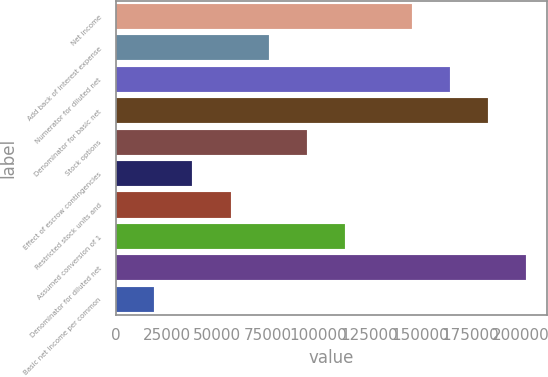<chart> <loc_0><loc_0><loc_500><loc_500><bar_chart><fcel>Net income<fcel>Add back of interest expense<fcel>Numerator for diluted net<fcel>Denominator for basic net<fcel>Stock options<fcel>Effect of escrow contingencies<fcel>Restricted stock units and<fcel>Assumed conversion of 1<fcel>Denominator for diluted net<fcel>Basic net income per common<nl><fcel>145913<fcel>75463.7<fcel>164779<fcel>183644<fcel>94329.4<fcel>37732.2<fcel>56597.9<fcel>113195<fcel>202510<fcel>18866.5<nl></chart> 